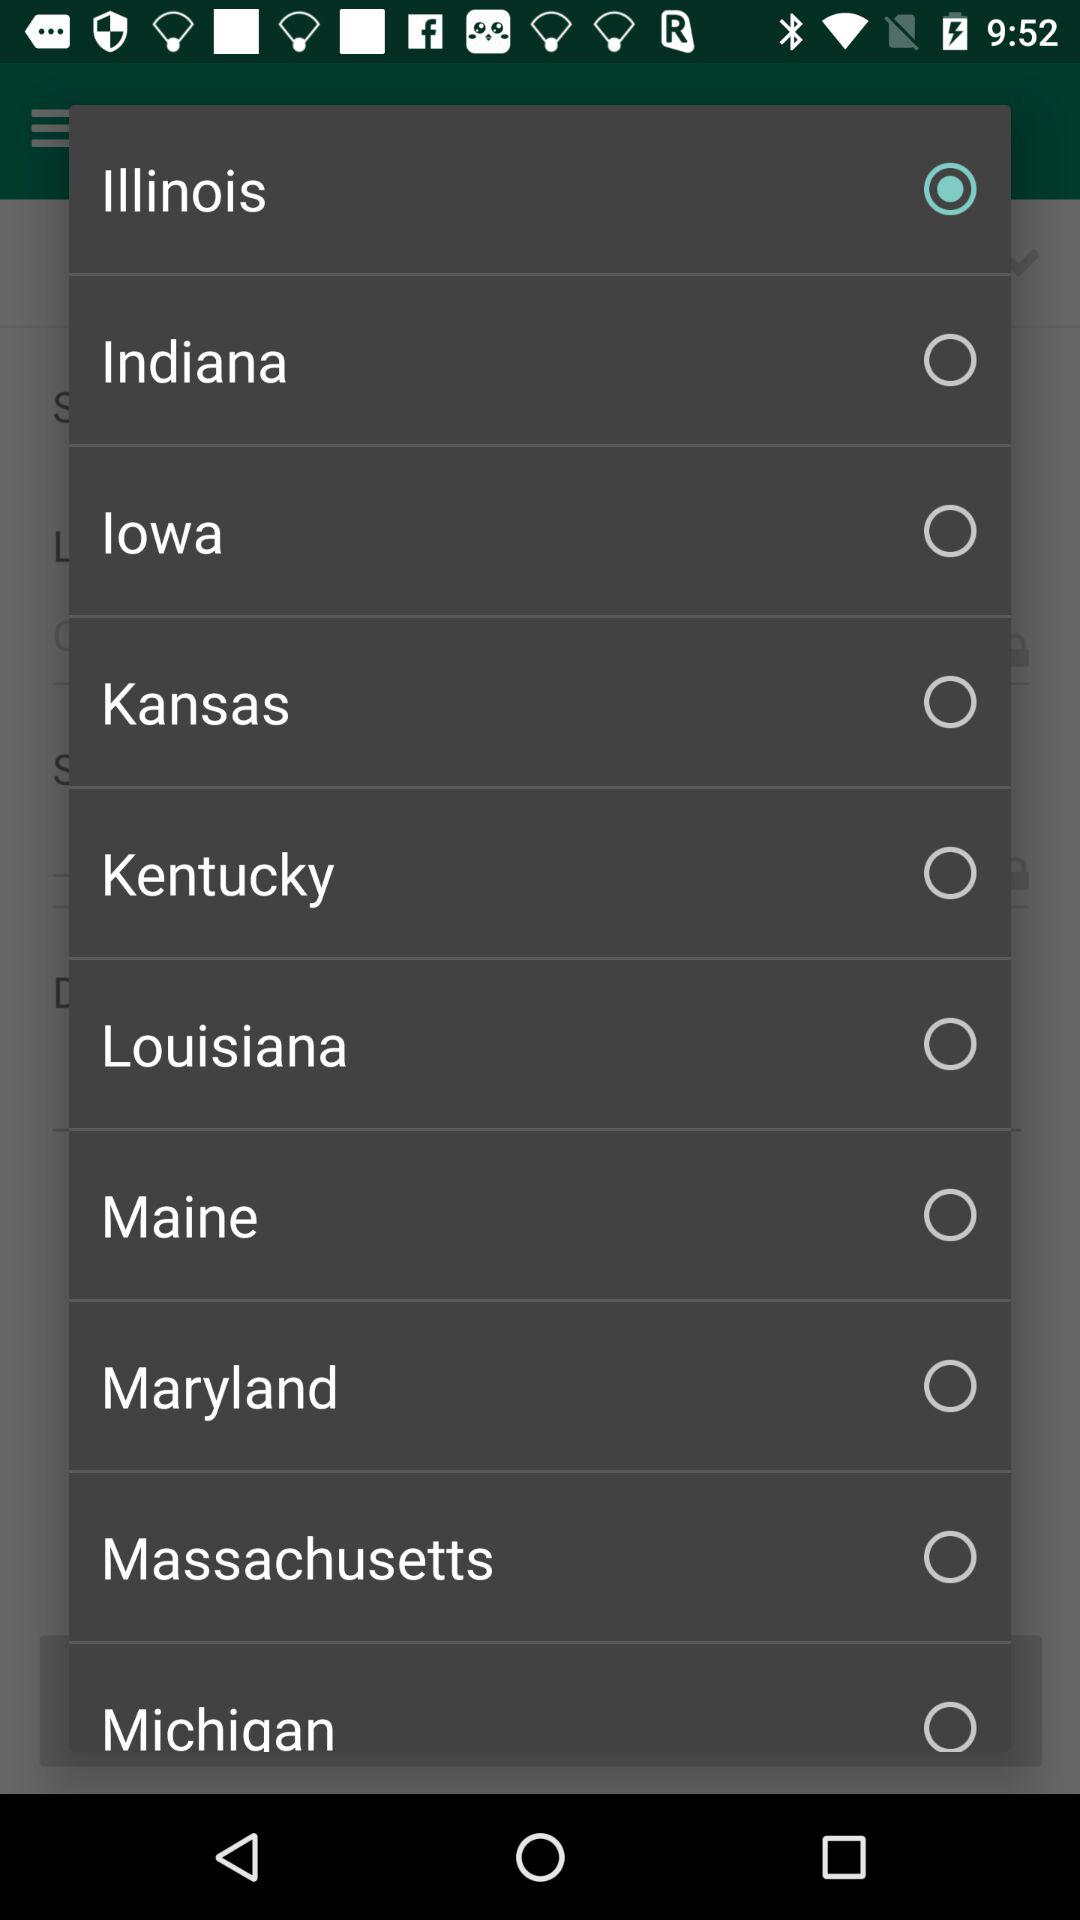Which option has been selected? The selected option is "Illinois". 